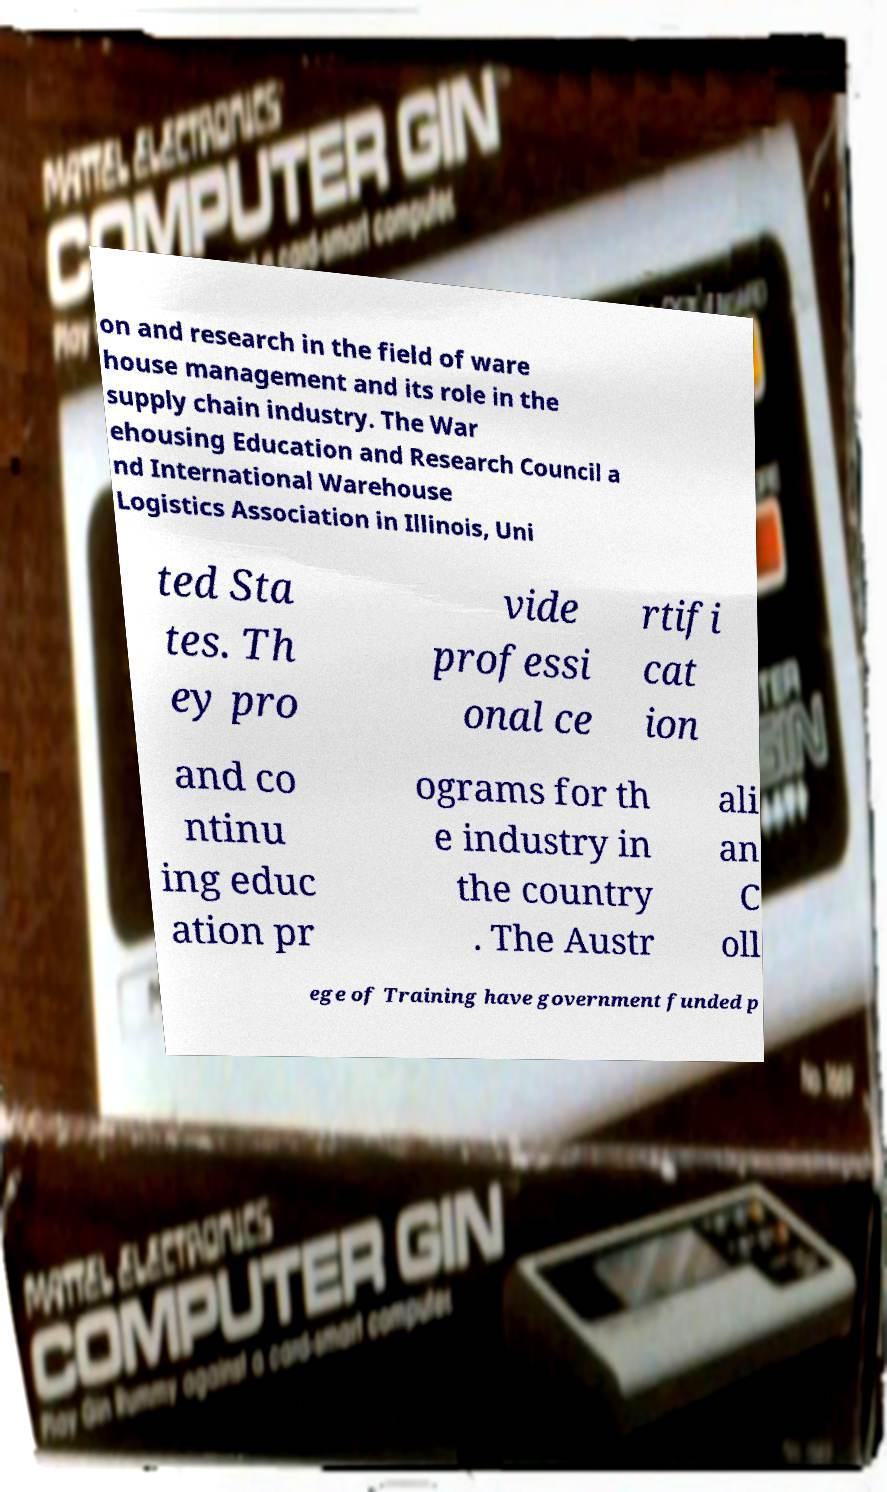Can you accurately transcribe the text from the provided image for me? on and research in the field of ware house management and its role in the supply chain industry. The War ehousing Education and Research Council a nd International Warehouse Logistics Association in Illinois, Uni ted Sta tes. Th ey pro vide professi onal ce rtifi cat ion and co ntinu ing educ ation pr ograms for th e industry in the country . The Austr ali an C oll ege of Training have government funded p 